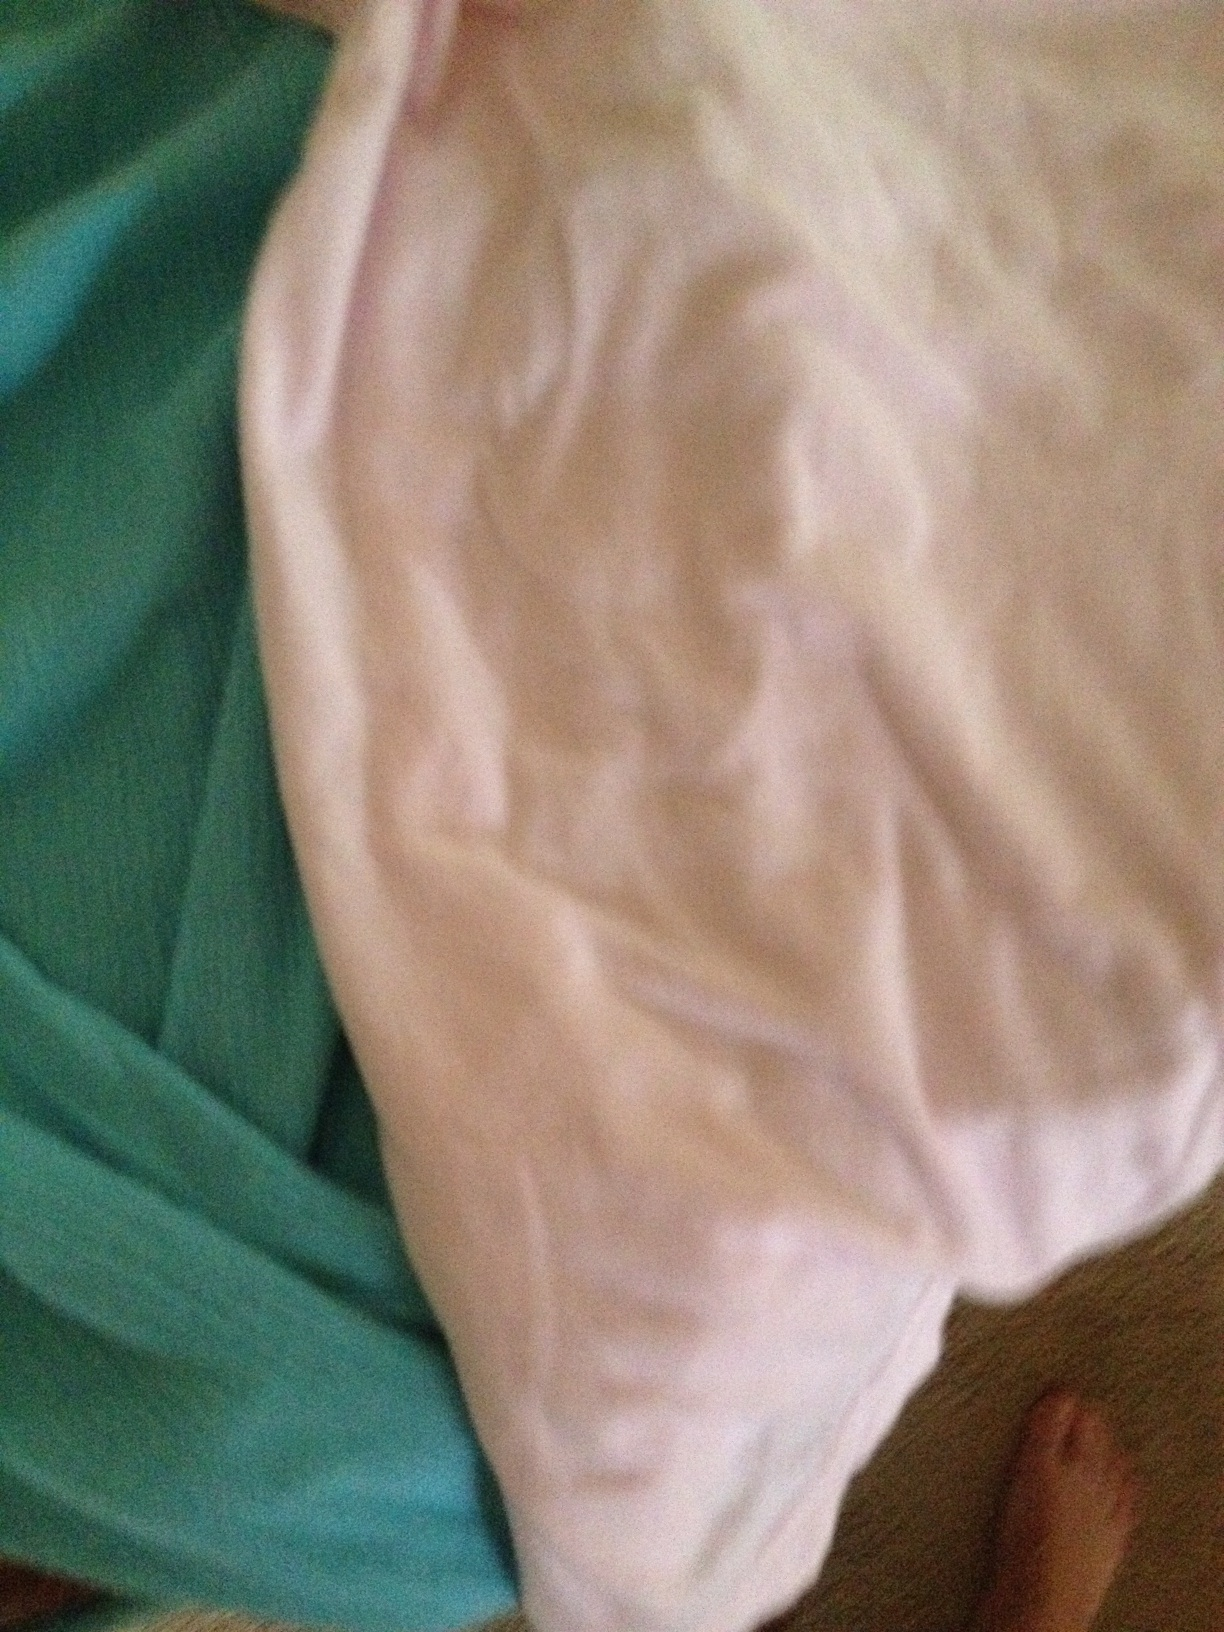Do not know if I have gotten of both pictures of both items. I would like to know if they go together, but you may have It's difficult to determine from the given image and the provided question whether the two items go together. The image shows two different cloth items, one teal and the other white. Without additional context or images, it's hard to ascertain if they belong together. Could you provide more details or another image for better evaluation? 